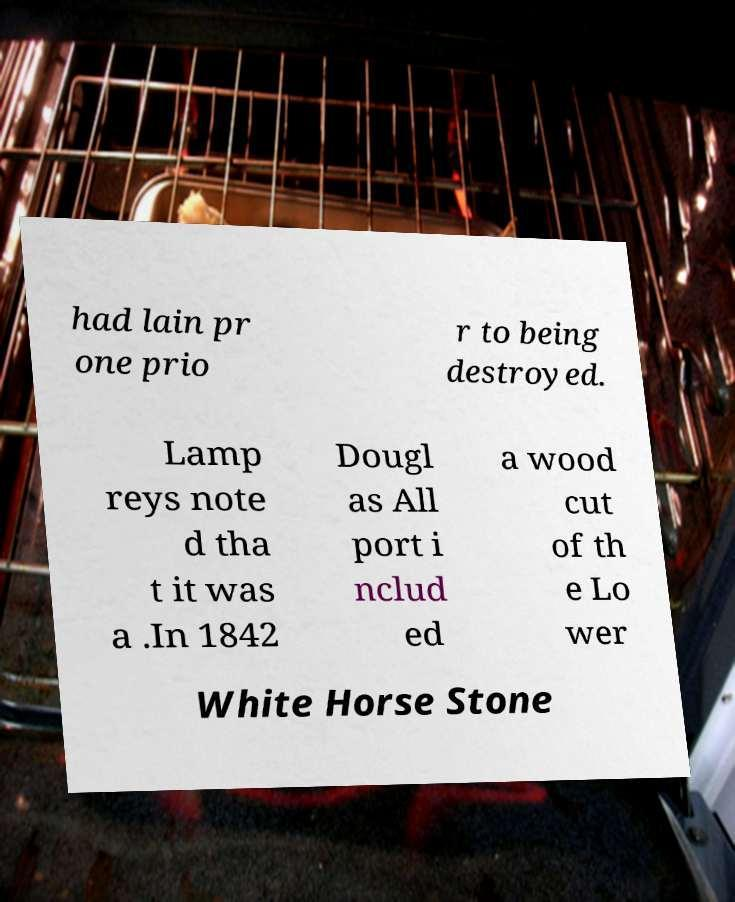Can you read and provide the text displayed in the image?This photo seems to have some interesting text. Can you extract and type it out for me? had lain pr one prio r to being destroyed. Lamp reys note d tha t it was a .In 1842 Dougl as All port i nclud ed a wood cut of th e Lo wer White Horse Stone 